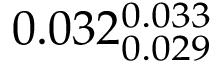<formula> <loc_0><loc_0><loc_500><loc_500>0 . 0 3 2 _ { 0 . 0 2 9 } ^ { 0 . 0 3 3 }</formula> 